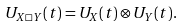Convert formula to latex. <formula><loc_0><loc_0><loc_500><loc_500>U _ { X \square Y } ( t ) = U _ { X } ( t ) \otimes U _ { Y } ( t ) .</formula> 